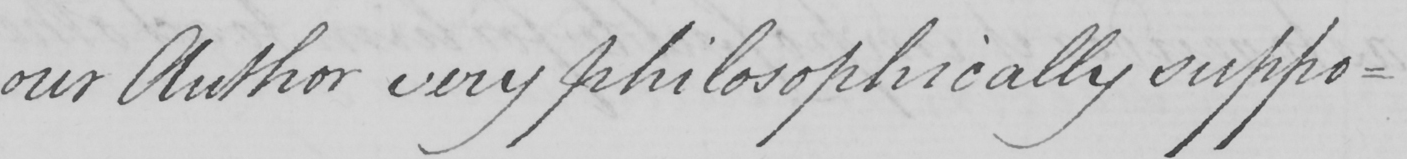Can you read and transcribe this handwriting? our Author very philosophically suppo- 